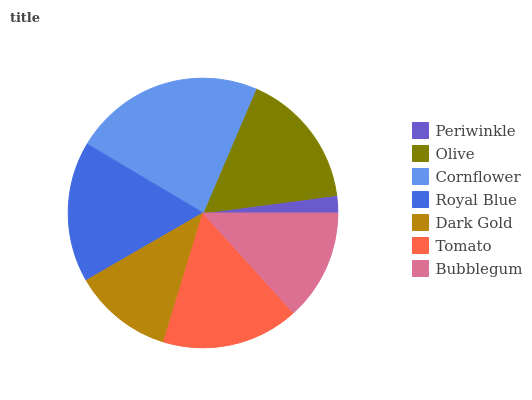Is Periwinkle the minimum?
Answer yes or no. Yes. Is Cornflower the maximum?
Answer yes or no. Yes. Is Olive the minimum?
Answer yes or no. No. Is Olive the maximum?
Answer yes or no. No. Is Olive greater than Periwinkle?
Answer yes or no. Yes. Is Periwinkle less than Olive?
Answer yes or no. Yes. Is Periwinkle greater than Olive?
Answer yes or no. No. Is Olive less than Periwinkle?
Answer yes or no. No. Is Tomato the high median?
Answer yes or no. Yes. Is Tomato the low median?
Answer yes or no. Yes. Is Royal Blue the high median?
Answer yes or no. No. Is Olive the low median?
Answer yes or no. No. 